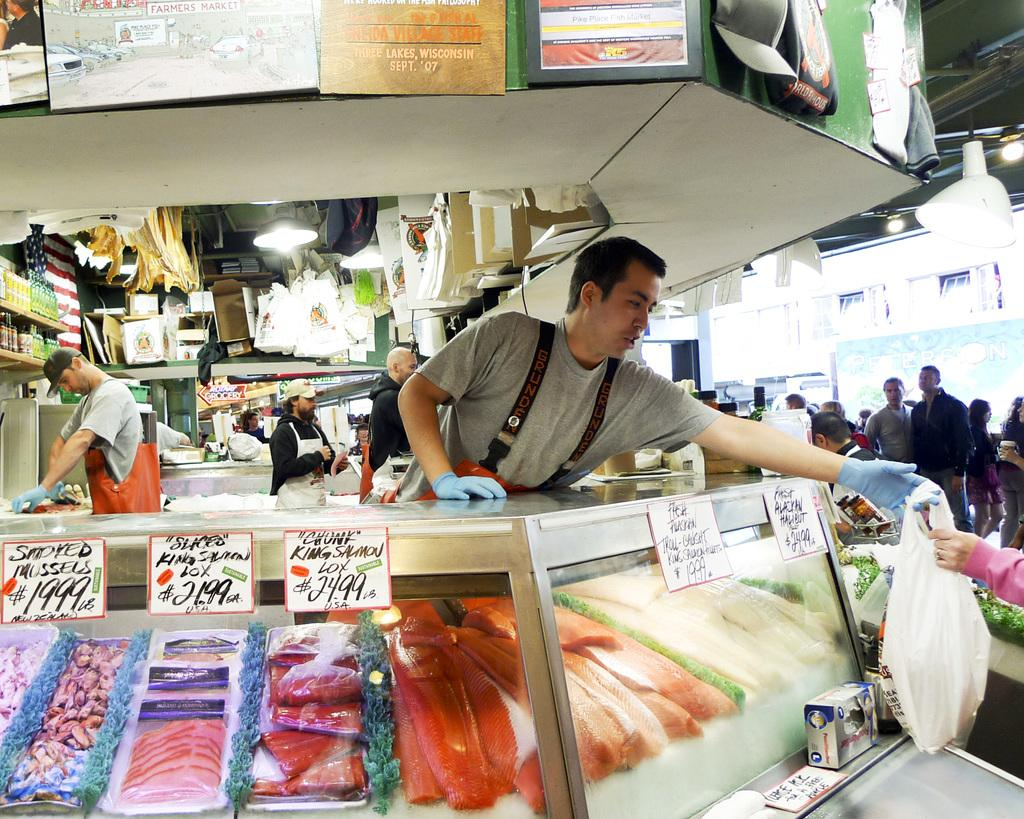<image>
Share a concise interpretation of the image provided. You can buy chunk king salmon lox for $24.99 per pound at this fish counter. 